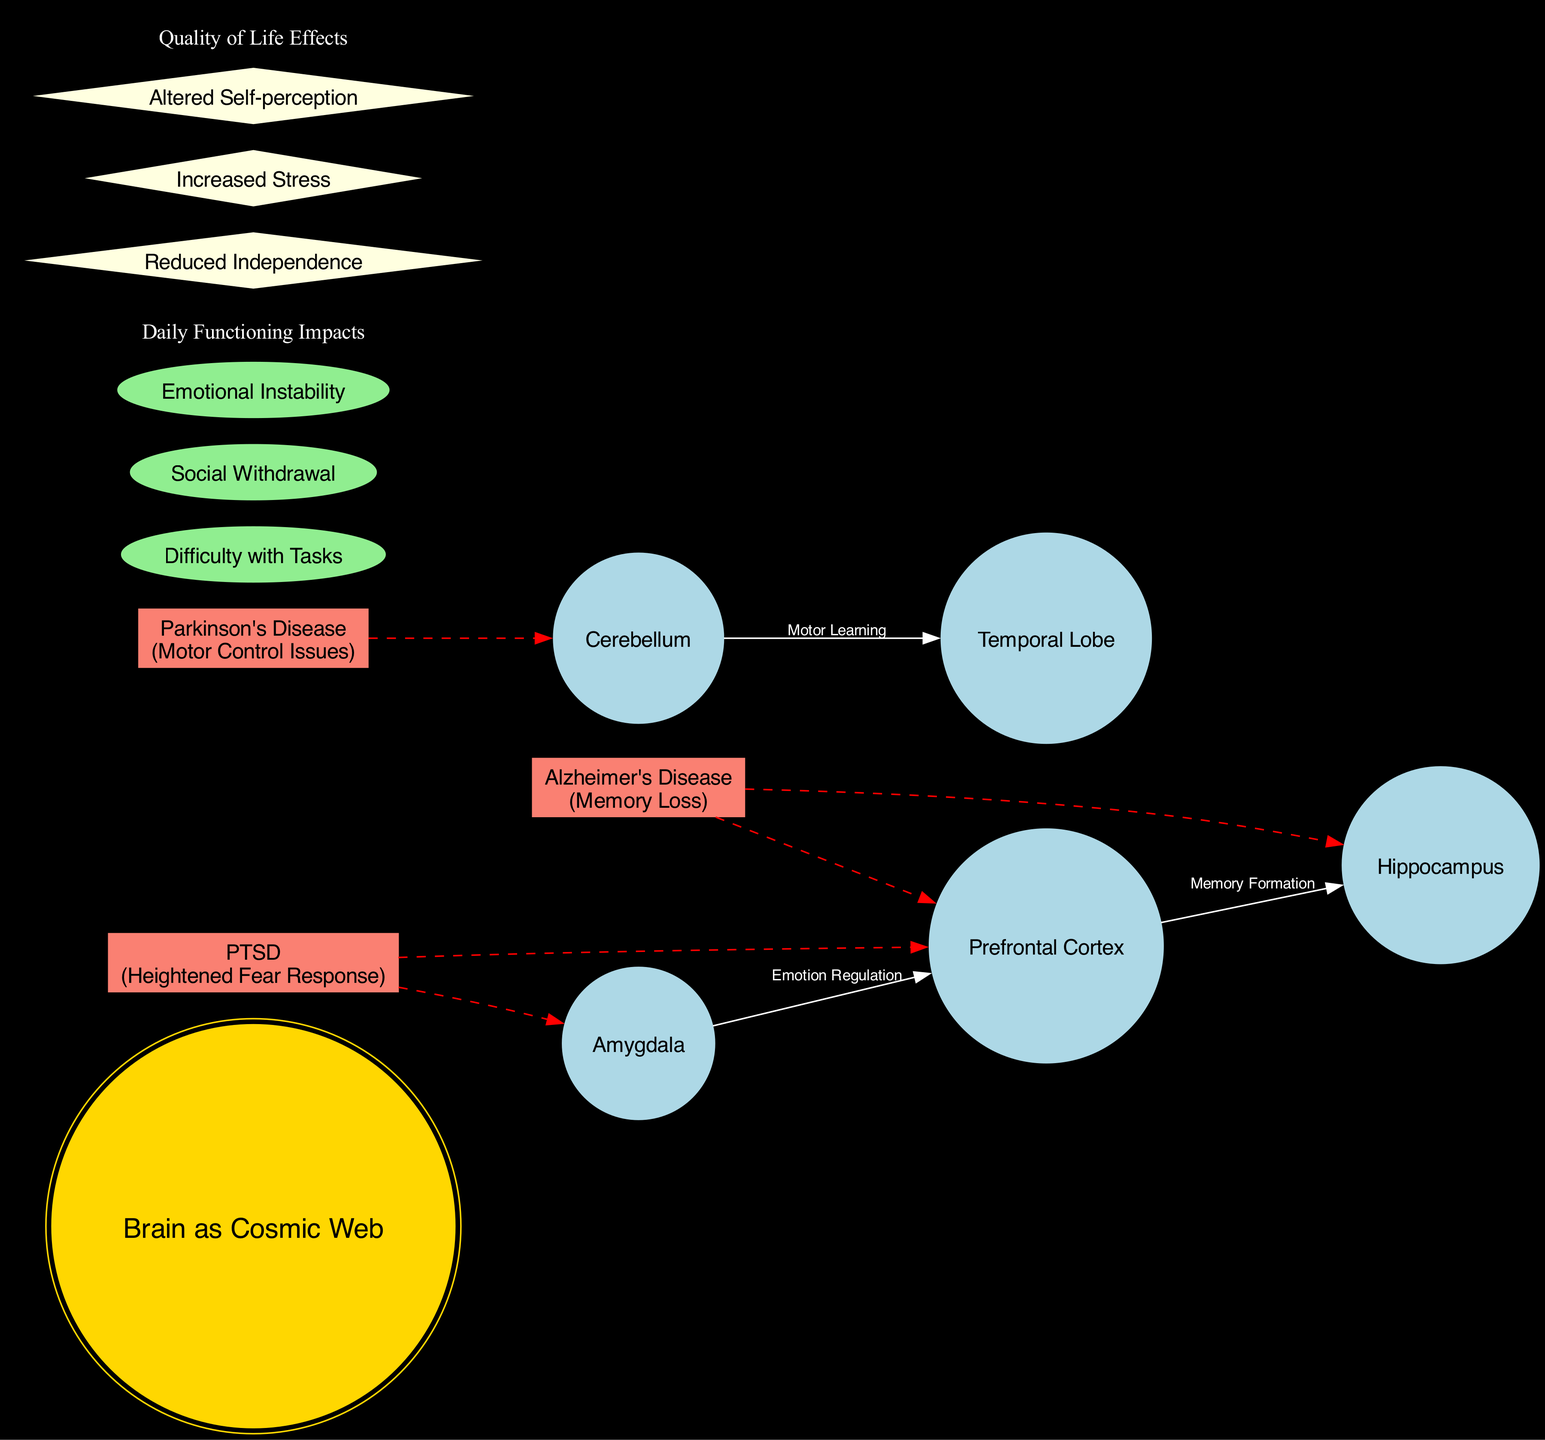What is the central node of the diagram? The diagram has a central node labeled "Brain as Cosmic Web," which serves as the main focus of the representation.
Answer: Brain as Cosmic Web How many major nodes are present in the diagram? The diagram lists five major nodes, which include Prefrontal Cortex, Hippocampus, Amygdala, Cerebellum, and Temporal Lobe.
Answer: 5 What is the relationship between the Prefrontal Cortex and the Hippocampus? The diagram indicates a connection between the Prefrontal Cortex and the Hippocampus labeled "Memory Formation," meaning they are linked through this functional connection.
Answer: Memory Formation Which cognitive impairment affects the Amygdala? The diagram shows that PTSD is the cognitive impairment that directly affects the Amygdala, highlighting its relevance in cognitive functioning.
Answer: PTSD What is one symptom associated with Alzheimer's Disease depicted in the diagram? The diagram presents the symptom of "Memory Loss" as associated with Alzheimer's Disease, which clarifies its impact on cognitive abilities.
Answer: Memory Loss Which node has a dashed edge connection with the Cerebellum? The diagram indicates that Parkinson's Disease has a dashed edge connection leading to the Cerebellum, signifying its influence on that part of the brain.
Answer: Parkinson's Disease What are the daily functioning impacts mentioned in the diagram? The diagram lists impacts such as "Difficulty with Tasks," "Social Withdrawal," and "Emotional Instability," reflecting the various challenges faced in daily life due to cognitive impairments.
Answer: Difficulty with Tasks, Social Withdrawal, Emotional Instability How does PTSD affect emotional regulation? The diagram connects PTSD to both the Amygdala and the Prefrontal Cortex, indicating that it impacts emotional regulation by influencing these brain regions.
Answer: Heightened Fear Response What effect does cognitive impairment have on quality of life according to the diagram? The diagram depicts effects such as "Reduced Independence," "Increased Stress," and "Altered Self-perception" as significant quality of life issues stemming from cognitive impairments.
Answer: Reduced Independence, Increased Stress, Altered Self-perception 